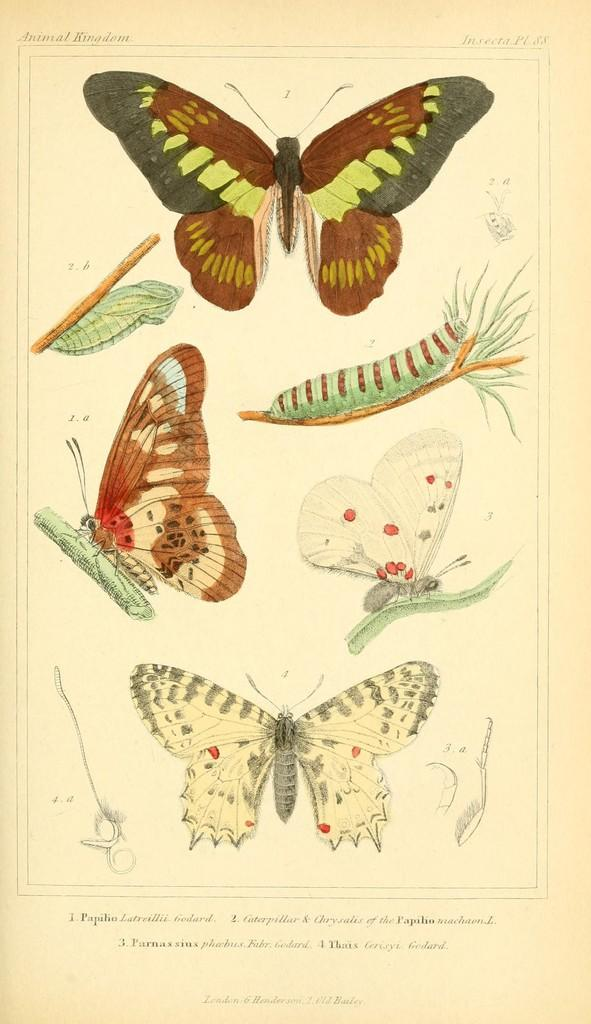What is depicted in the paintings in the image? There are paintings of butterflies in the image. What is the background color of the paintings? The paintings are on a white paper. Is there any text present in the image? Yes, there is text at the bottom of the paper. How many sisters can be seen in the image? There are no sisters present in the image; it features paintings of butterflies on a white paper with text at the bottom. 